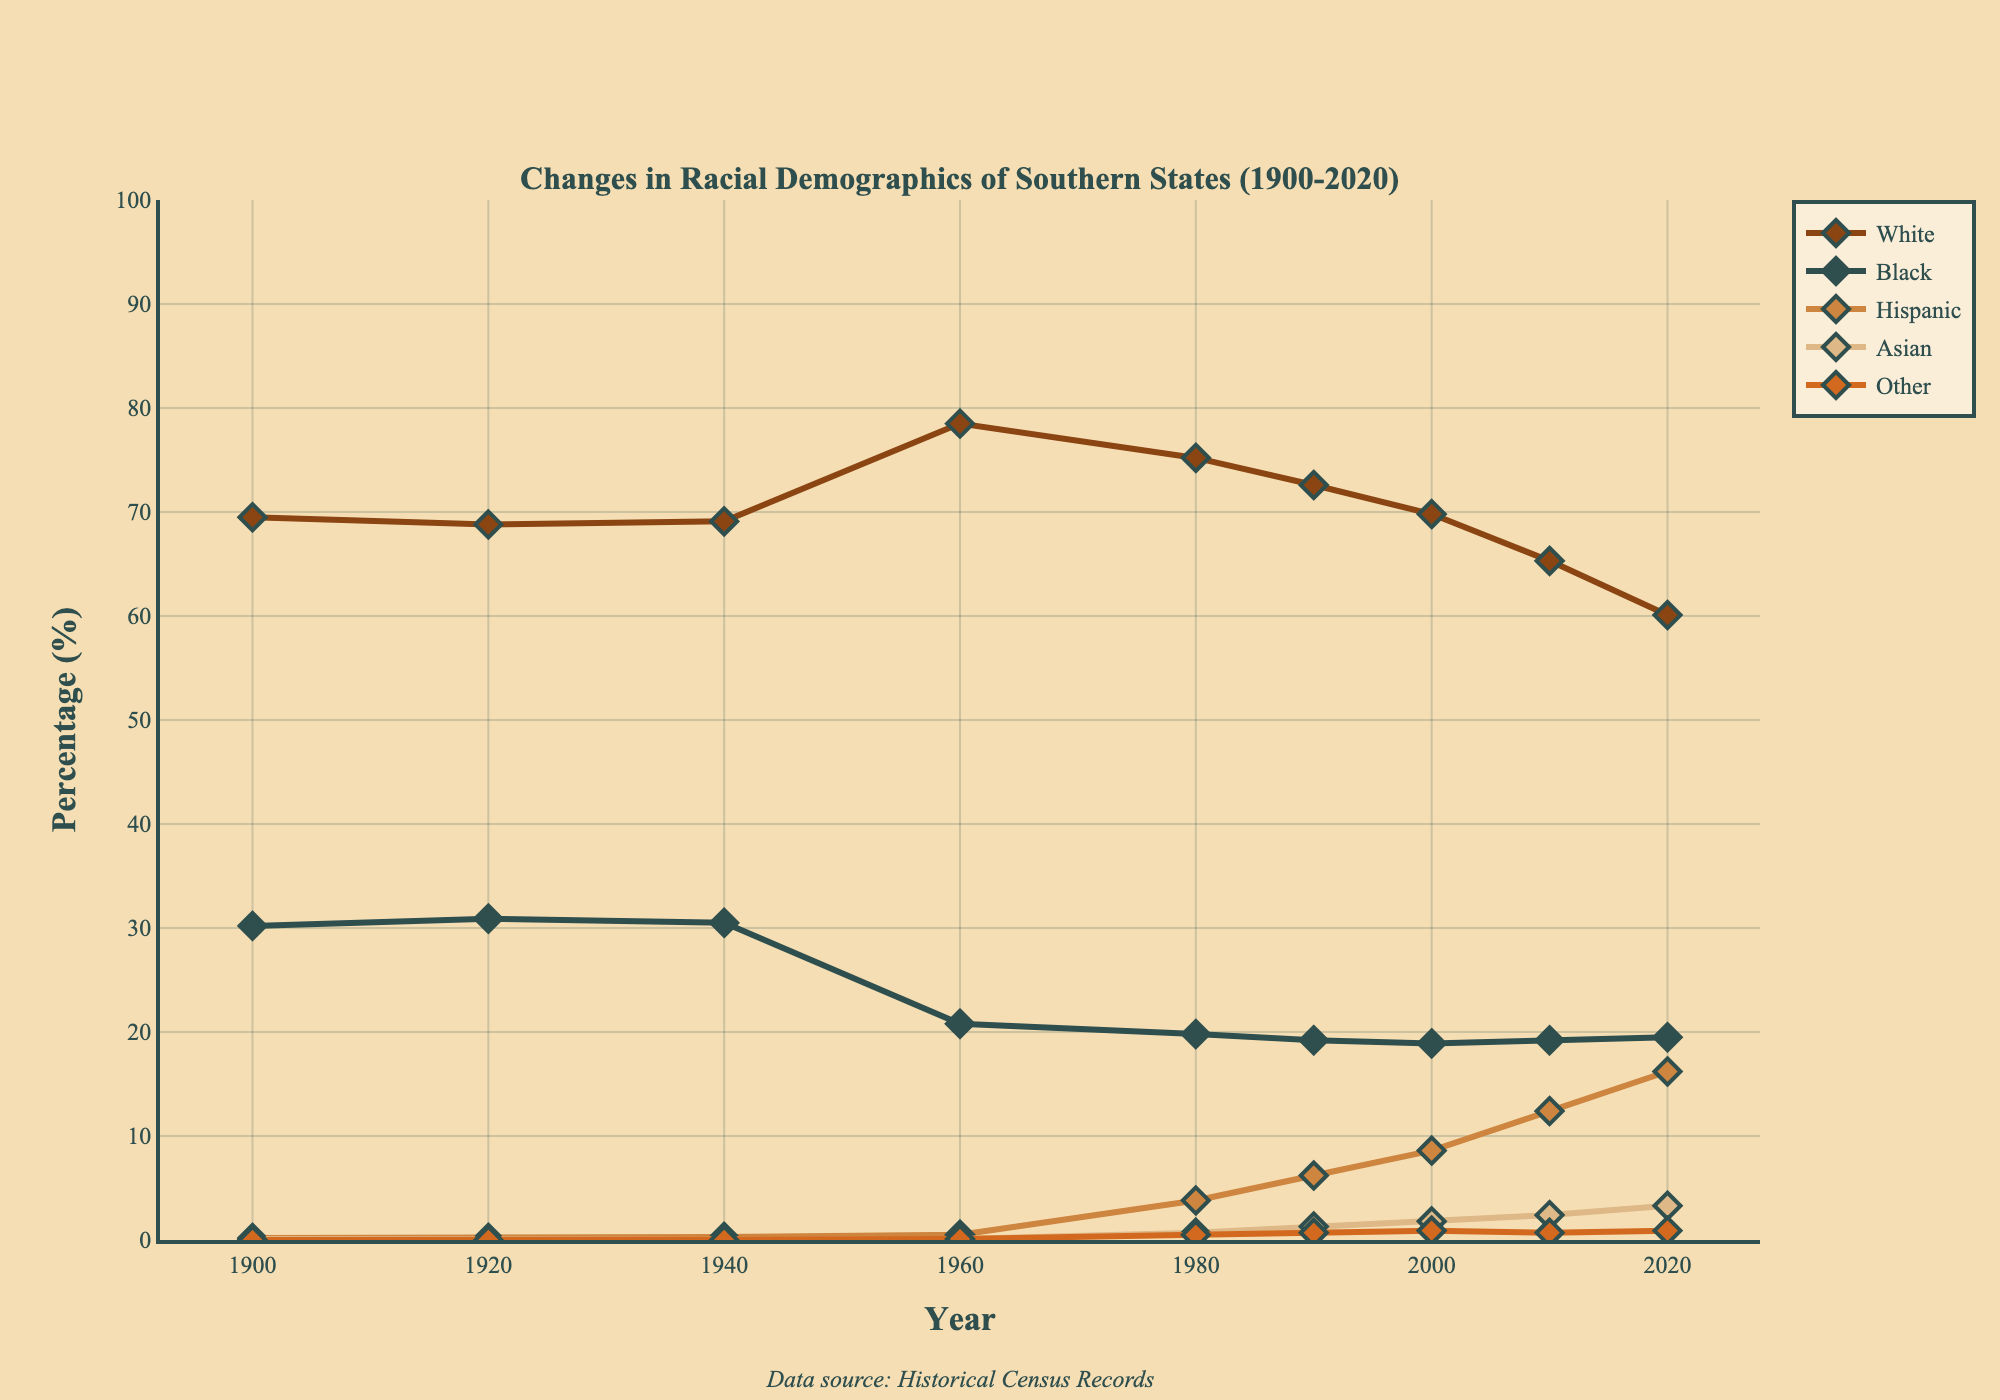What trend can you observe for the "White" demographic from 1900 to 2020? By examining the line representing the "White" demographic, we observe a consistent decrease in percentage from 1960 onward, after a brief increase from 1940 to 1960. The trend suggests a gradual decline in the proportion of the "White" population.
Answer: The "White" demographic shows a decreasing trend from 1960 to 2020 Which year did the "Hispanic" demographic start increasing significantly? By looking at the "Hispanic" line, a noticeable increase starts around 1980. The percentage rises more prominently after this point compared to earlier years where it remained relatively low.
Answer: 1980 How do the percentages of the "Black" demographic in 1920 and 2020 compare? From the figure, the percentage of the "Black" demographic in 1920 is approximately 30.9%, while in 2020 it is about 19.5%. Comparing these two figures, we see a significant decrease over the 100-year period.
Answer: 30.9% in 1920 and 19.5% in 2020 What is the difference in the percentage of the "Asian" demographic between 1980 and 2020? In 1980, the "Asian" demographic is at roughly 0.7%, and it increases to about 3.3% by 2020. Subtracting these values gives the difference: 3.3% - 0.7% = 2.6%.
Answer: 2.6% Between which two decades did the "Hispanic" demographic see the greatest increase? By examining the slopes of the "Hispanic" line, the most significant increase occurs between 2000 and 2010, where the percentage rises sharply from 8.6% to 12.4%. This is a rise of 3.8%, the largest observed increase over a decade.
Answer: 2000 to 2010 Calculate the average percentage of the "Other" demographic from 1960 to 2020. First, we identify the values for the "Other" demographic in each decade between 1960 and 2020. These values are 0.1% (1960), 0.5% (1980), 0.7% (1990), 0.9% (2000), 0.7% (2010), and 0.9% (2020). Summing these percentages: 0.1 + 0.5 + 0.7 + 0.9 + 0.7 + 0.9 = 3.8. There are six values, so the average is 3.8 / 6 = 0.633%, approximately.
Answer: 0.633% What can you infer about the "White" and "Black" demographics' combined percentage trend from 1960 to 2020? Summing the percentages of "White" and "Black" for each decade from 1960 to 2020, we observe the following combined values: (78.5 + 20.8) = 99.3, (75.2 + 19.8) = 95.0, (72.6 + 19.2) = 91.8, (69.8 + 18.9) = 88.7, (65.3 + 19.2) = 84.5, (60.1 + 19.5) = 79.6. The combined trend shows a decreasing pattern over this period, indicating a reduction in the majority population percentages.
Answer: Combined trend is decreasing 